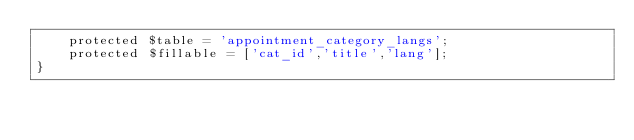<code> <loc_0><loc_0><loc_500><loc_500><_PHP_>    protected $table = 'appointment_category_langs';
    protected $fillable = ['cat_id','title','lang'];
}
</code> 